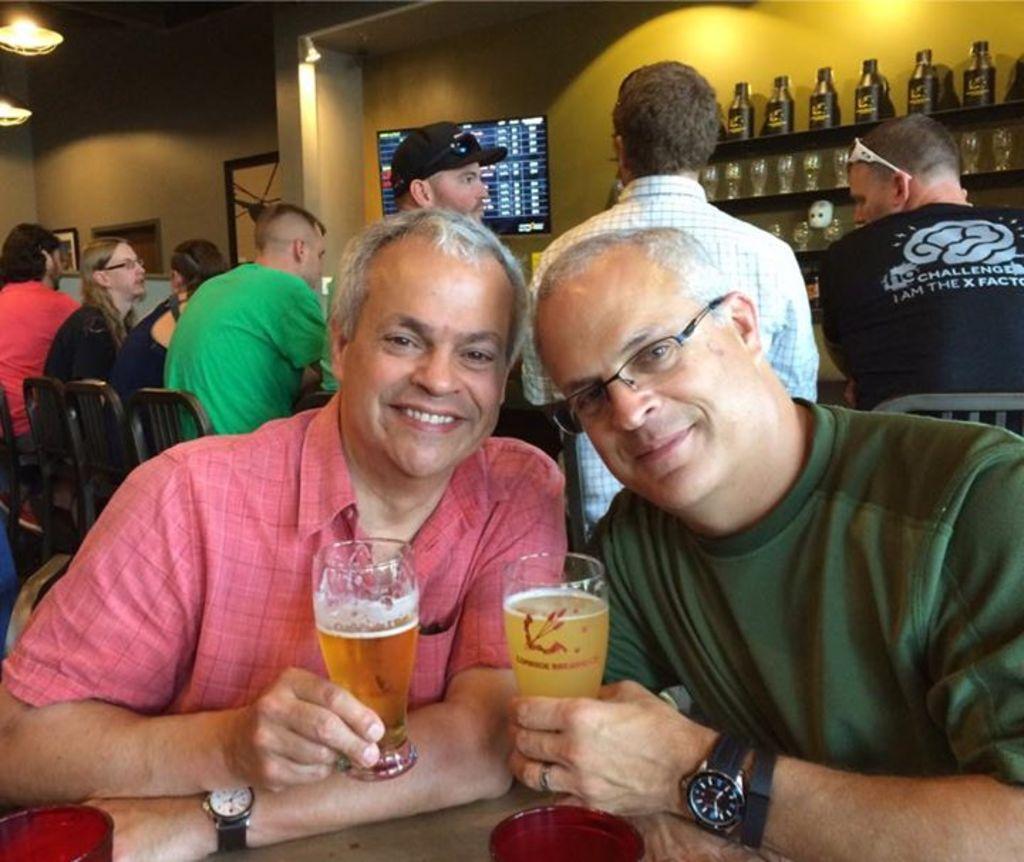Could you give a brief overview of what you see in this image? There are two men sitting in the chairs in front of a table holding drink glasses in their hands. In the background, there are some people sitting and having their drinks. We can observe some bottles in the wall here with the television 